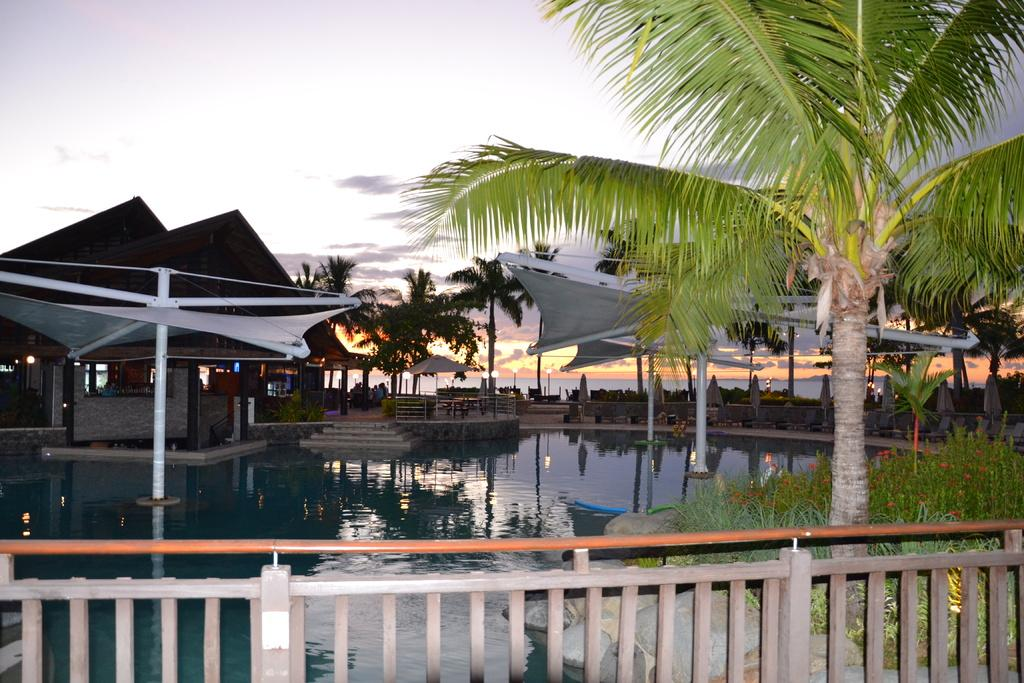What type of vegetation can be seen in the image? There are trees in the image. What is the color of the trees? The trees are green. What can be seen in the background of the image? There is a shed, stairs, and people sitting in the background of the image. What is the color of the sky in the image? The sky is gray in color. Can you tell me where the drum is located in the image? There is no drum present in the image. Is the snow visible in the image? There is no snow visible in the image; the trees are green, and the sky is gray. 